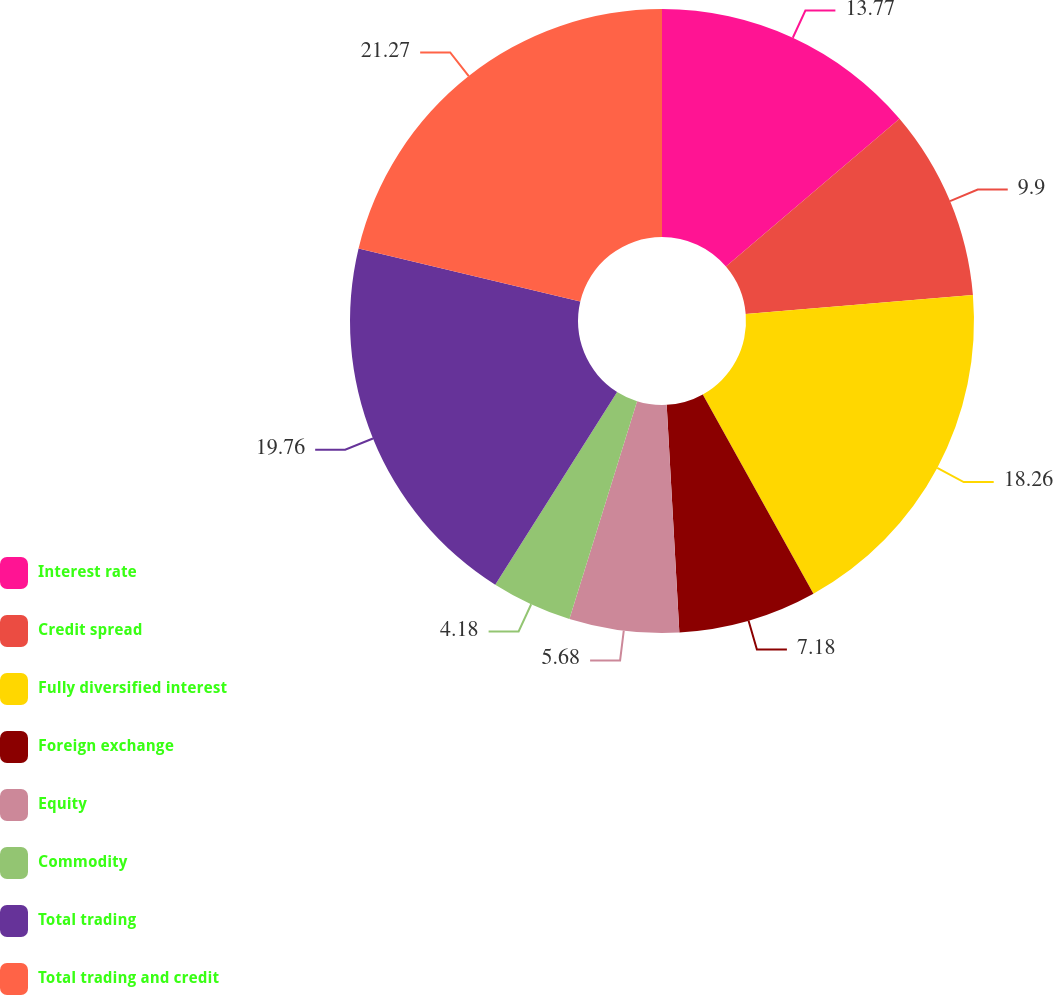Convert chart to OTSL. <chart><loc_0><loc_0><loc_500><loc_500><pie_chart><fcel>Interest rate<fcel>Credit spread<fcel>Fully diversified interest<fcel>Foreign exchange<fcel>Equity<fcel>Commodity<fcel>Total trading<fcel>Total trading and credit<nl><fcel>13.77%<fcel>9.9%<fcel>18.26%<fcel>7.18%<fcel>5.68%<fcel>4.18%<fcel>19.76%<fcel>21.26%<nl></chart> 